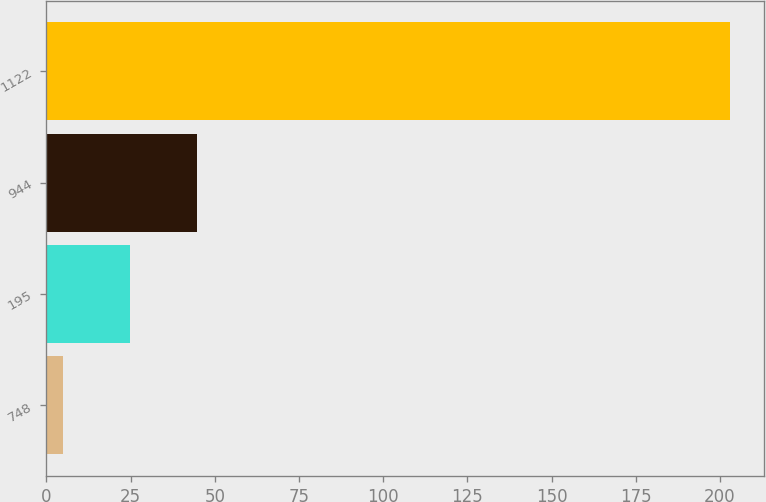Convert chart. <chart><loc_0><loc_0><loc_500><loc_500><bar_chart><fcel>748<fcel>195<fcel>944<fcel>1122<nl><fcel>5<fcel>24.8<fcel>44.6<fcel>203<nl></chart> 